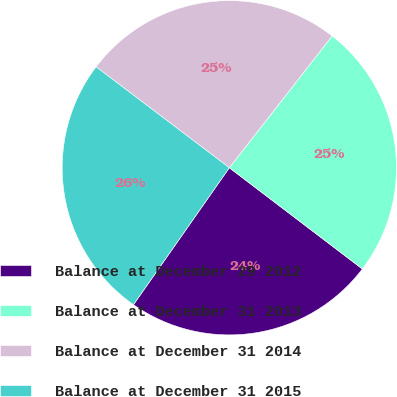<chart> <loc_0><loc_0><loc_500><loc_500><pie_chart><fcel>Balance at December 29 2012<fcel>Balance at December 31 2013<fcel>Balance at December 31 2014<fcel>Balance at December 31 2015<nl><fcel>24.37%<fcel>24.81%<fcel>25.22%<fcel>25.6%<nl></chart> 